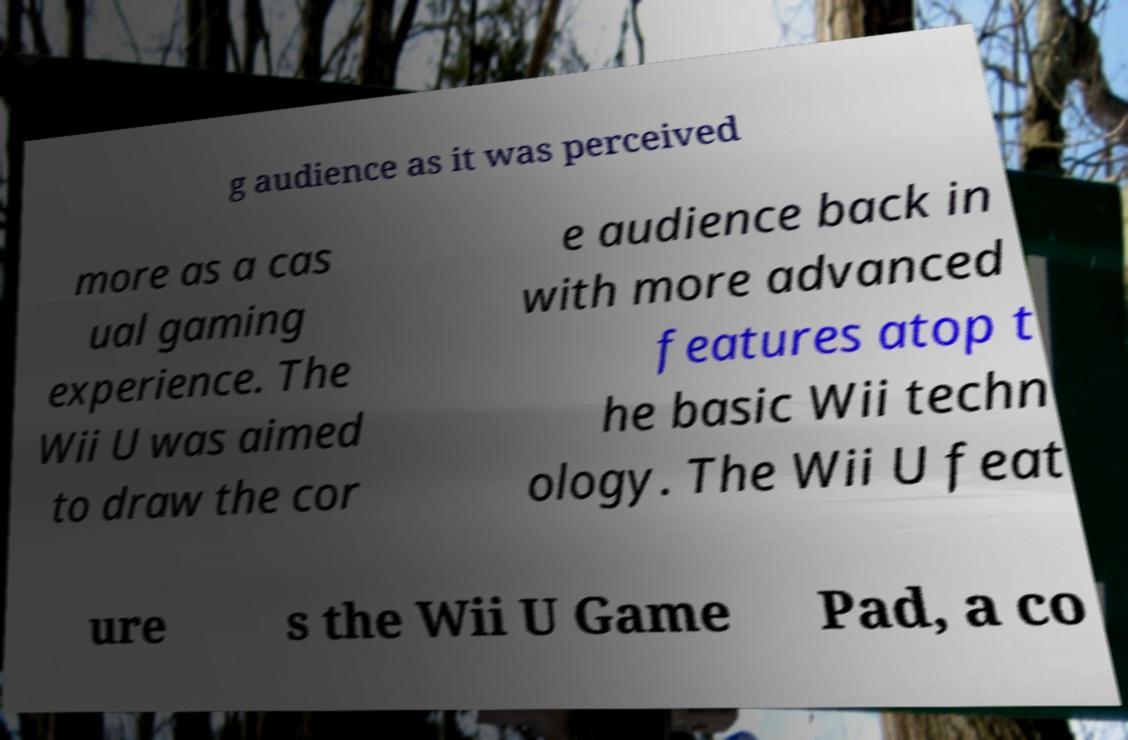Could you extract and type out the text from this image? g audience as it was perceived more as a cas ual gaming experience. The Wii U was aimed to draw the cor e audience back in with more advanced features atop t he basic Wii techn ology. The Wii U feat ure s the Wii U Game Pad, a co 